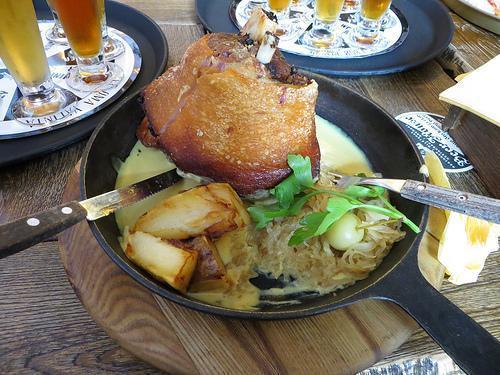How many forks are in the picture?
Give a very brief answer. 1. 